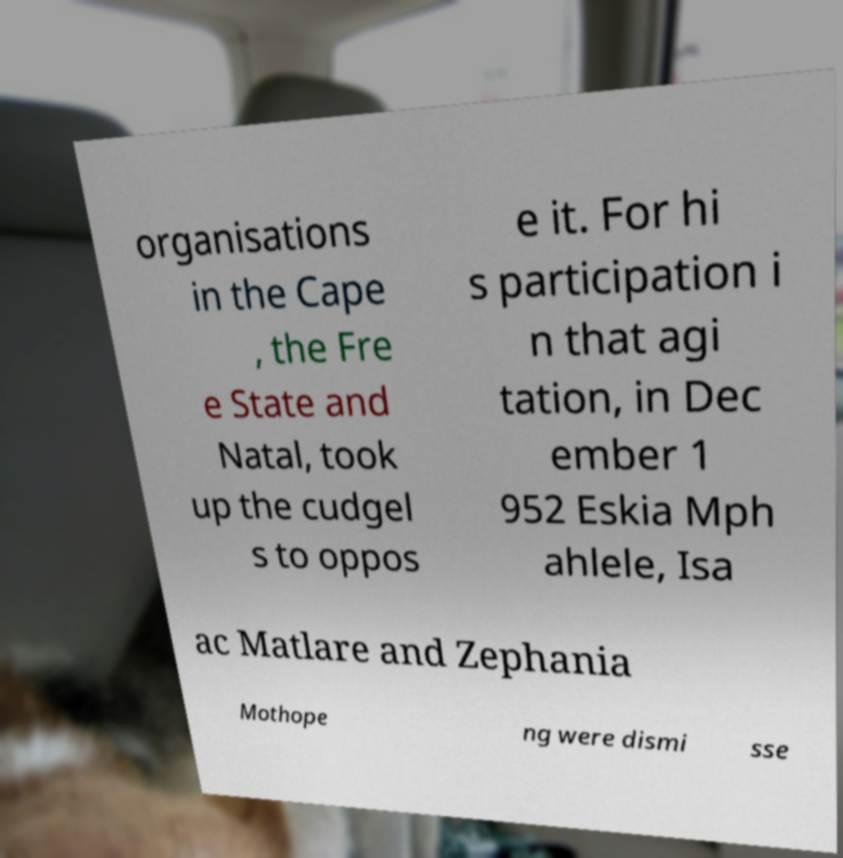For documentation purposes, I need the text within this image transcribed. Could you provide that? organisations in the Cape , the Fre e State and Natal, took up the cudgel s to oppos e it. For hi s participation i n that agi tation, in Dec ember 1 952 Eskia Mph ahlele, Isa ac Matlare and Zephania Mothope ng were dismi sse 